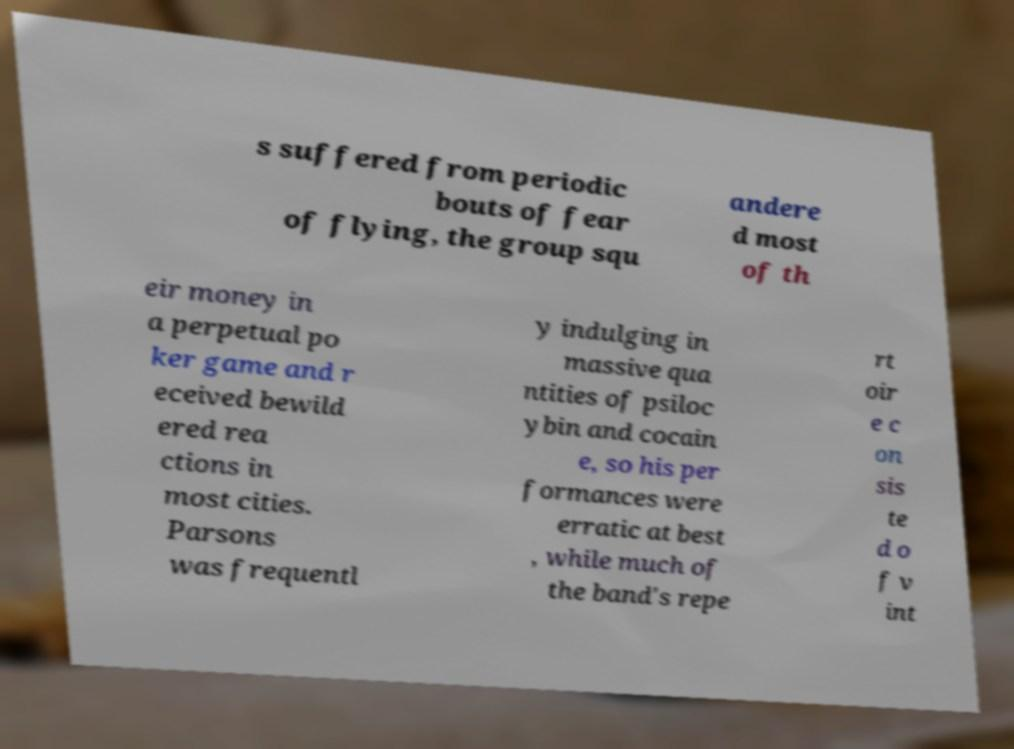Could you extract and type out the text from this image? s suffered from periodic bouts of fear of flying, the group squ andere d most of th eir money in a perpetual po ker game and r eceived bewild ered rea ctions in most cities. Parsons was frequentl y indulging in massive qua ntities of psiloc ybin and cocain e, so his per formances were erratic at best , while much of the band's repe rt oir e c on sis te d o f v int 